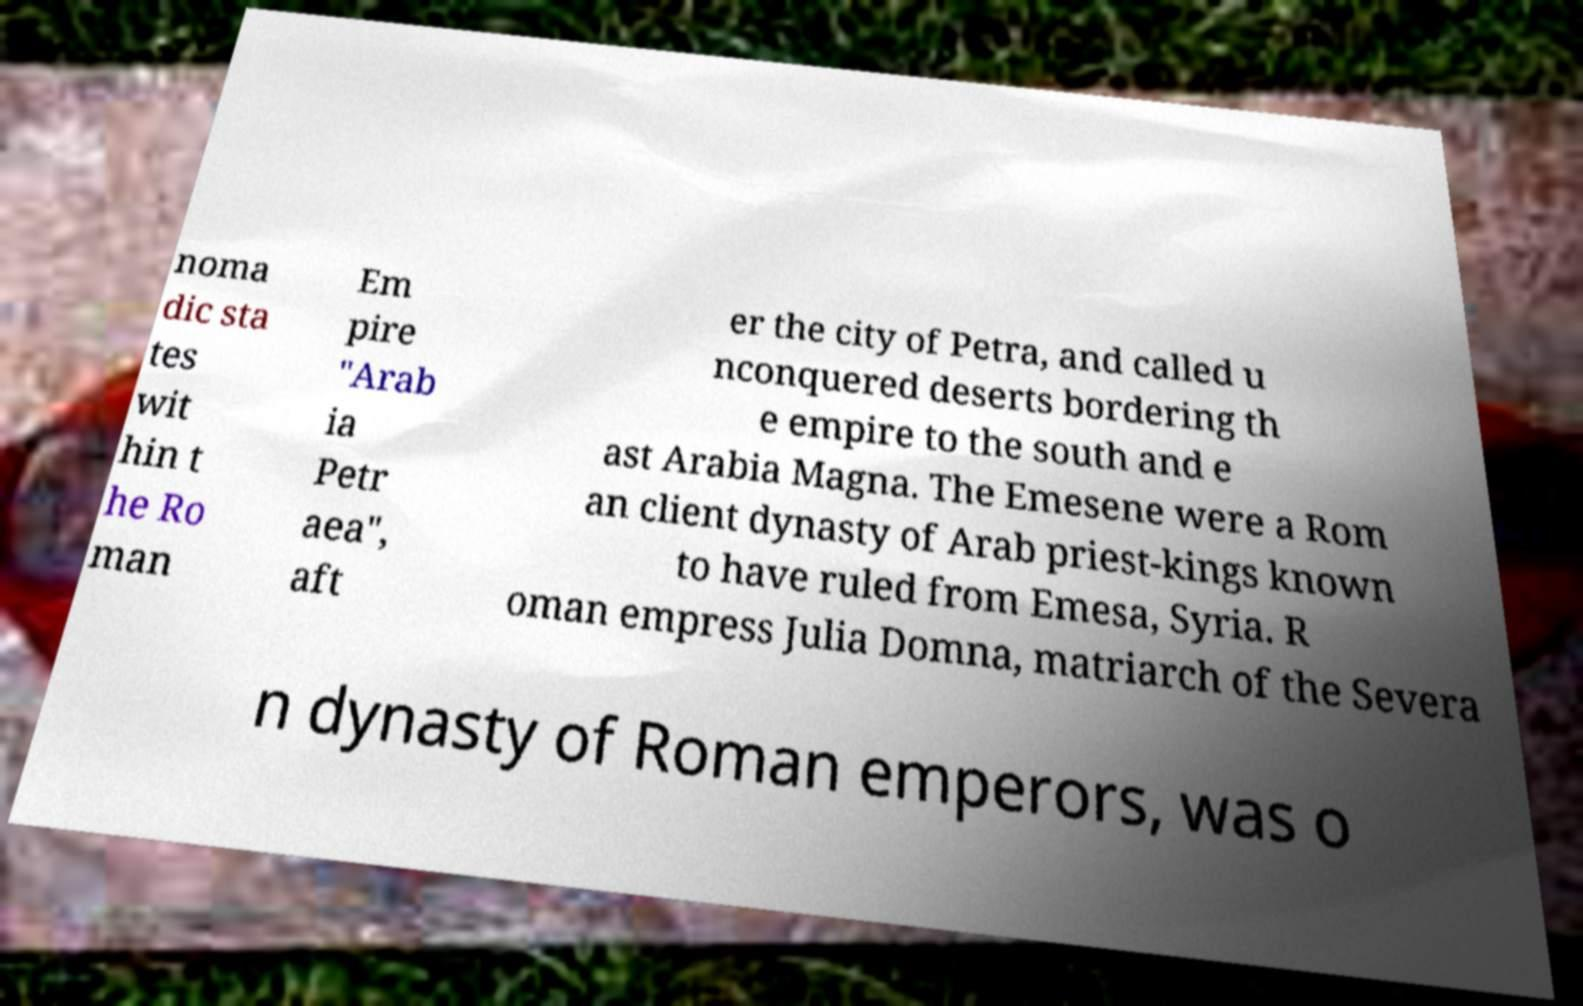For documentation purposes, I need the text within this image transcribed. Could you provide that? noma dic sta tes wit hin t he Ro man Em pire "Arab ia Petr aea", aft er the city of Petra, and called u nconquered deserts bordering th e empire to the south and e ast Arabia Magna. The Emesene were a Rom an client dynasty of Arab priest-kings known to have ruled from Emesa, Syria. R oman empress Julia Domna, matriarch of the Severa n dynasty of Roman emperors, was o 